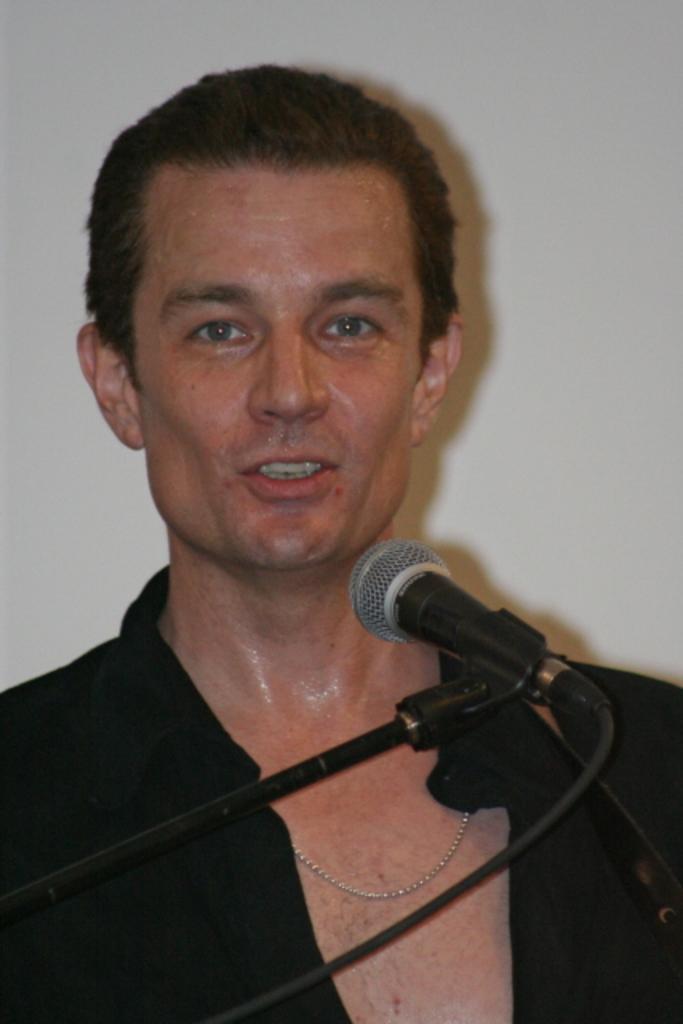In one or two sentences, can you explain what this image depicts? In this image there is a mike with a mike stand , a person, and at the background there is a wall. 